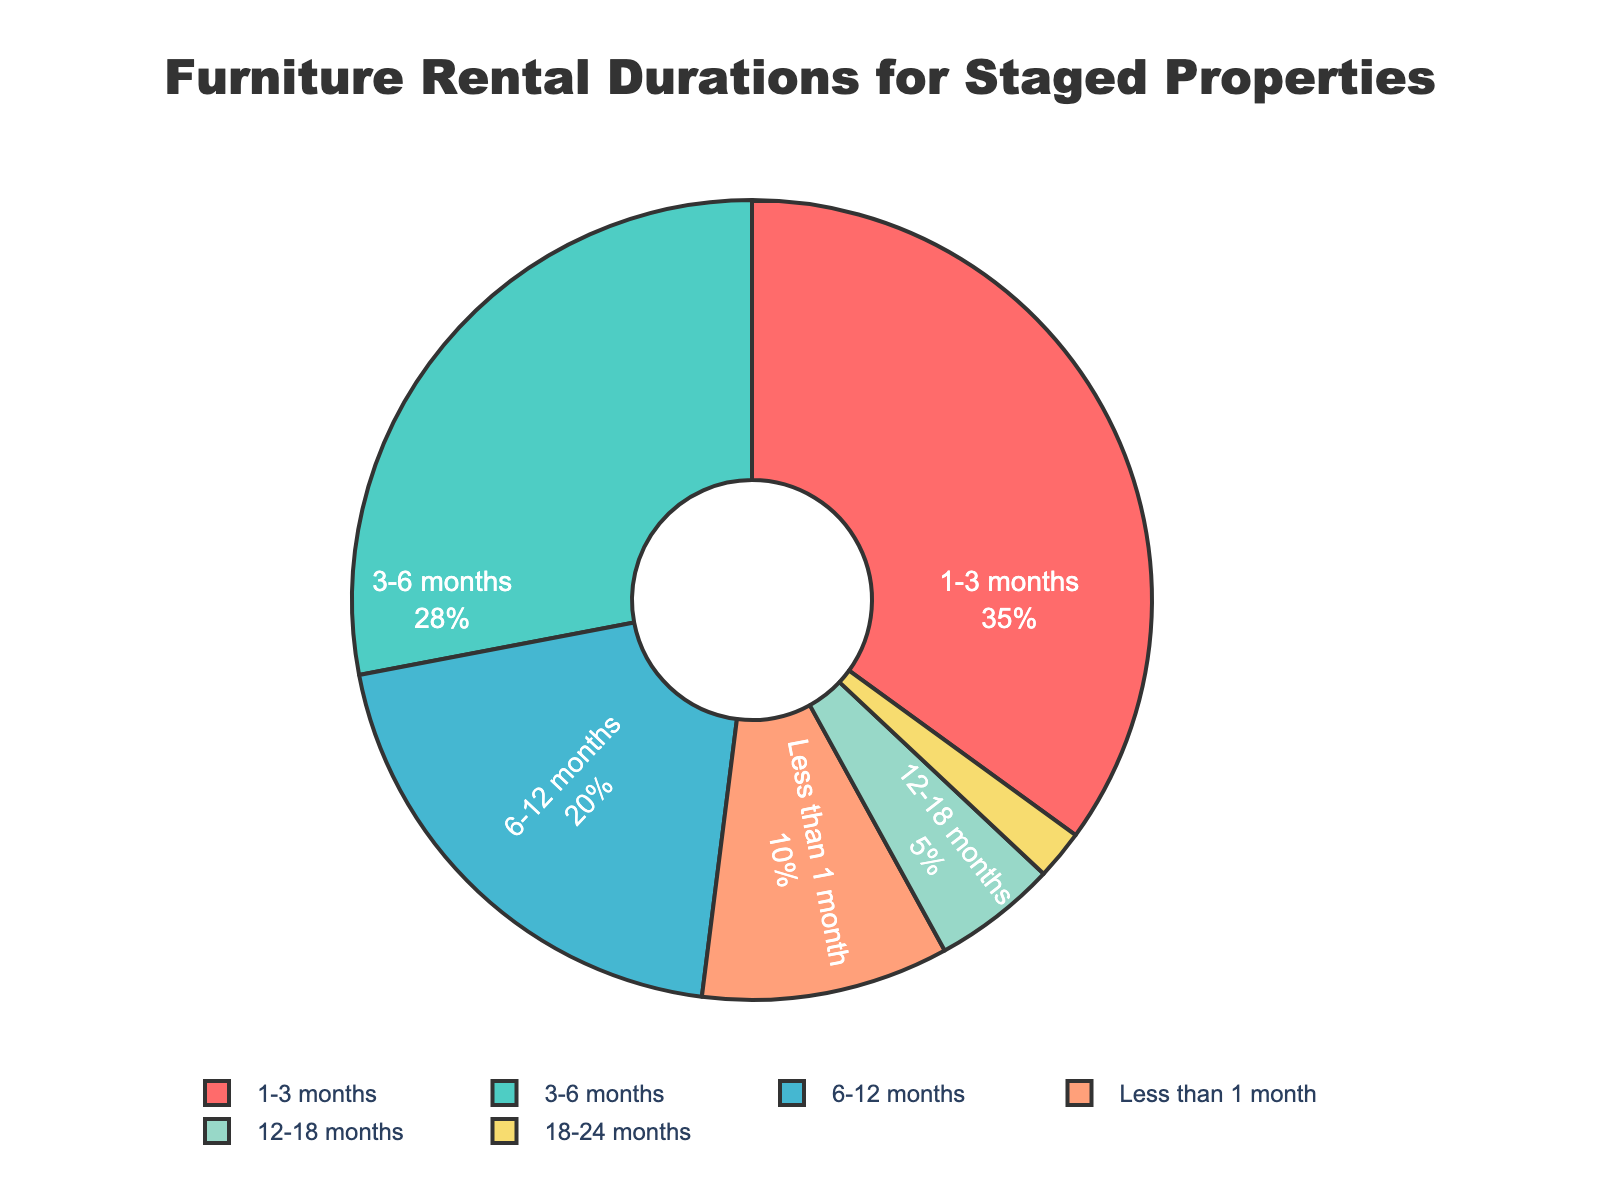What's the most common rental duration for staged properties? The most common rental duration is represented by the largest pie slice in the chart. This slice corresponds to the "1-3 months" category.
Answer: 1-3 months Which rental duration is shortest in terms of percentage? The shortest rental duration in terms of percentage is represented by the smallest pie slice. This slice corresponds to the "18-24 months" category.
Answer: 18-24 months What percentage of rentals last less than 6 months? To find the percentage of rentals lasting less than 6 months, sum up the percentages for "Less than 1 month," "1-3 months," and "3-6 months." So, 10% + 35% + 28% = 73%.
Answer: 73% How does the percentage of rentals lasting 6-12 months compare to those lasting 3-6 months? Look at the percentages for "6-12 months" and "3-6 months." "6-12 months" is 20%, and "3-6 months" is 28%. 20% is less than 28%.
Answer: Less What color represents the 12-18 months rental duration? The pie slice for the "12-18 months" rental duration is colored yellow.
Answer: Yellow Is there a larger percentage of rentals lasting "1-3 months" or "6-12 months"? Compare the percentages for "1-3 months" (35%) and "6-12 months" (20%). 35% is greater than 20%.
Answer: 1-3 months How much larger is the percentage of rentals lasting 1-3 months compared to those lasting 6-12 months? Subtract the percentage of "6-12 months" from the percentage of "1-3 months." That’s 35% - 20% = 15%.
Answer: 15% What is the total percentage of rentals lasting more than 12 months? Sum the percentages for "12-18 months" and "18-24 months." 5% + 2% = 7%.
Answer: 7% How much of the chart is occupied by rentals falling in 3-6 months category? The chart shows the size of the "3-6 months" slice as 28%.
Answer: 28% Are rentals of "Less than 1 month" more common than those of "12-18 months"? Compare the percentages for "Less than 1 month" (10%) and "12-18 months" (5%). 10% is greater than 5%.
Answer: Yes 